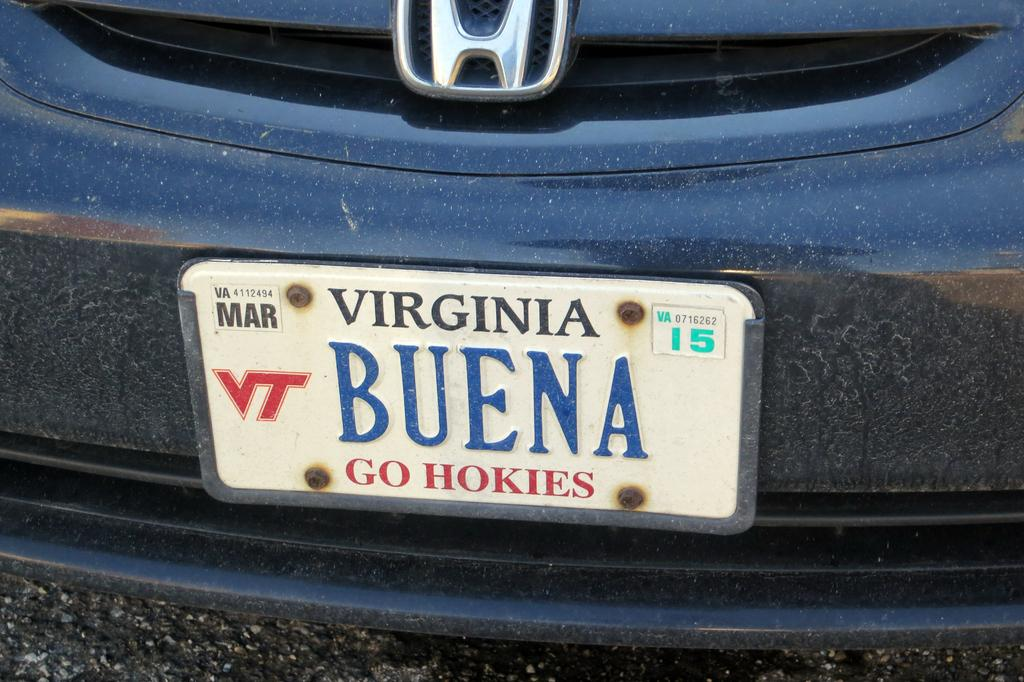<image>
Provide a brief description of the given image. Virginia license plate Buena Go Hokies on a blue Honda. 